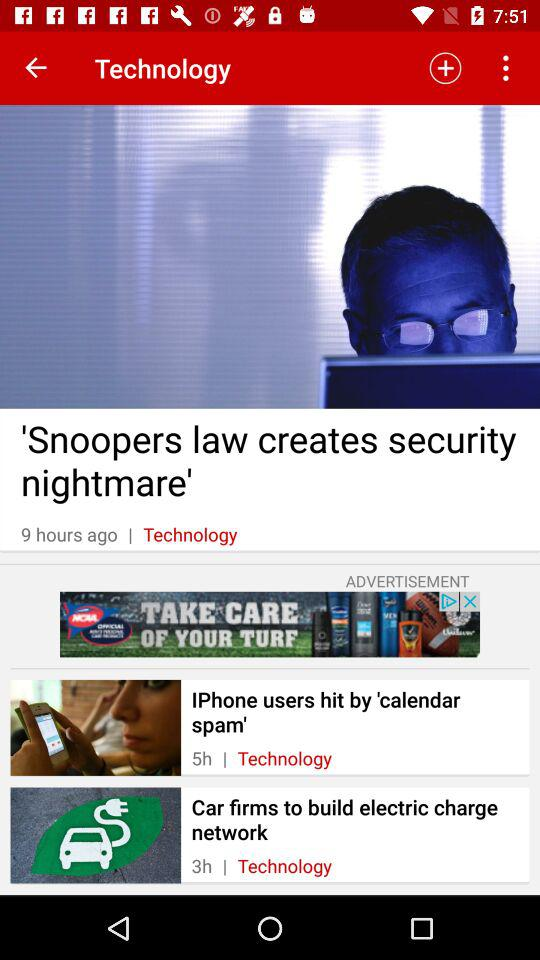How many hours ago was the article about the car firms to build electric charge network published?
Answer the question using a single word or phrase. 3 